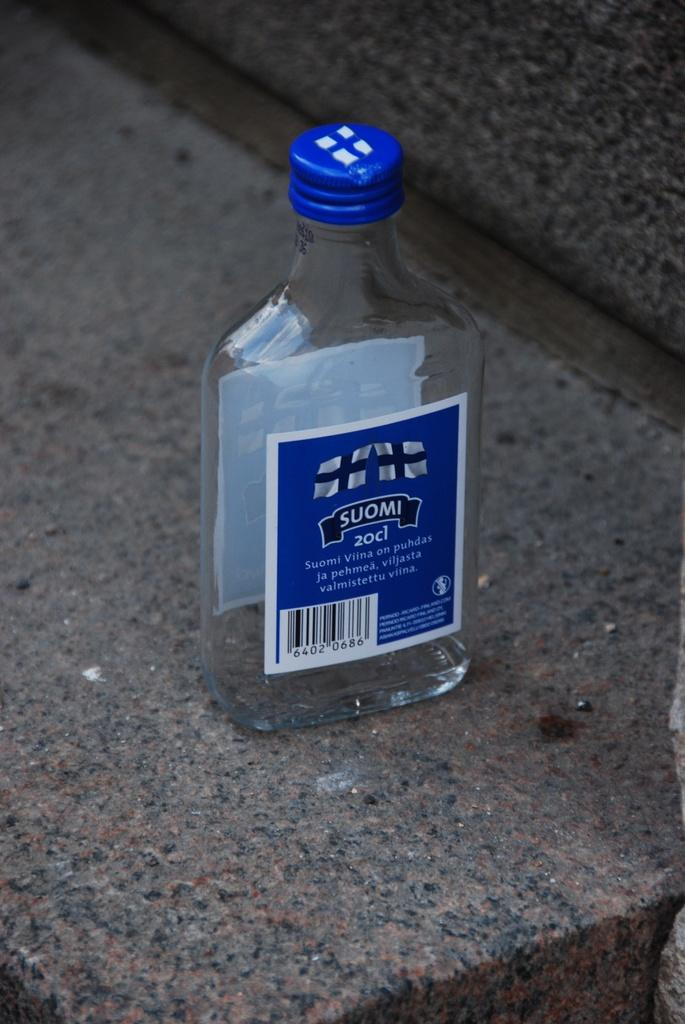Provide a one-sentence caption for the provided image. a small bottle sitting on stone that is labeled 'suomi 20cl'. 